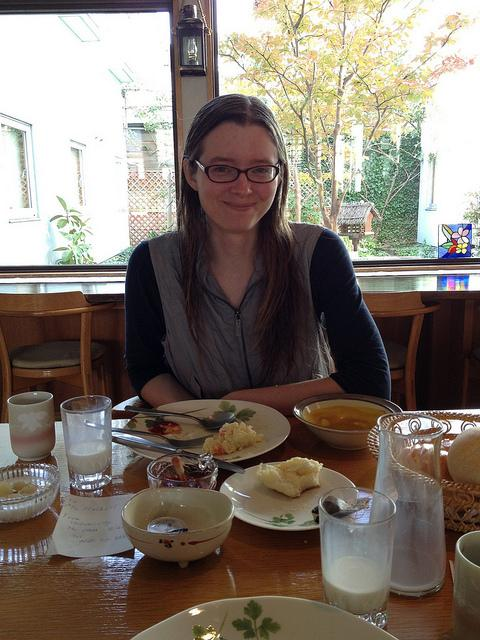How many people are likely enjoying this meal? one 